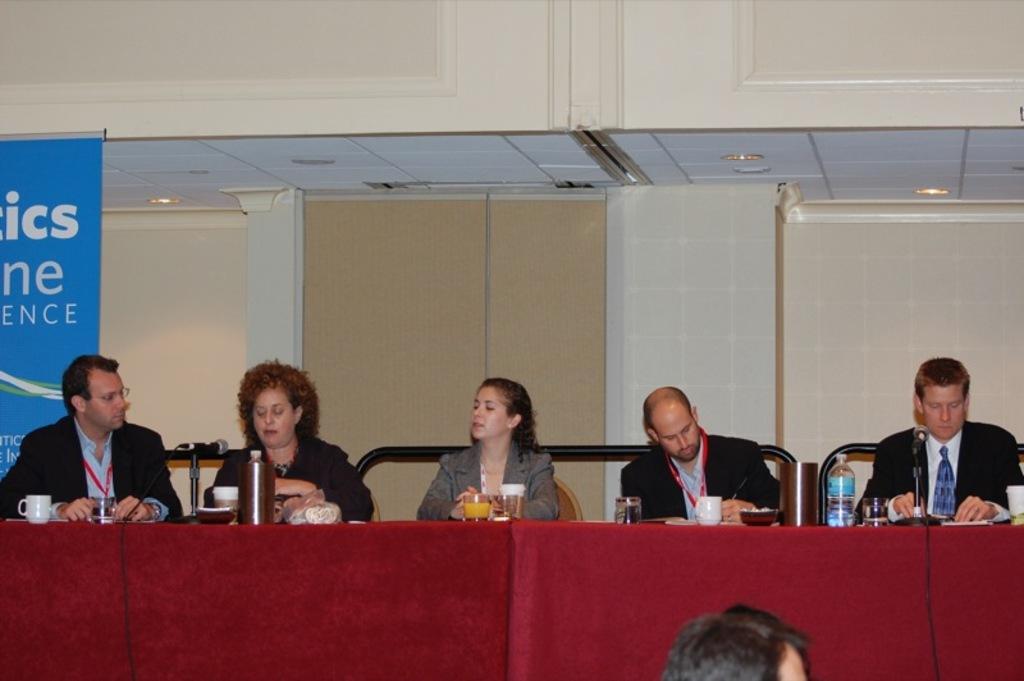In one or two sentences, can you explain what this image depicts? This picture describes about group of people, they are all seated on the chair, in front of them we can see cups, microphones, glasses, bottles on the table. In the background we can see hoarding and couple of lights. 